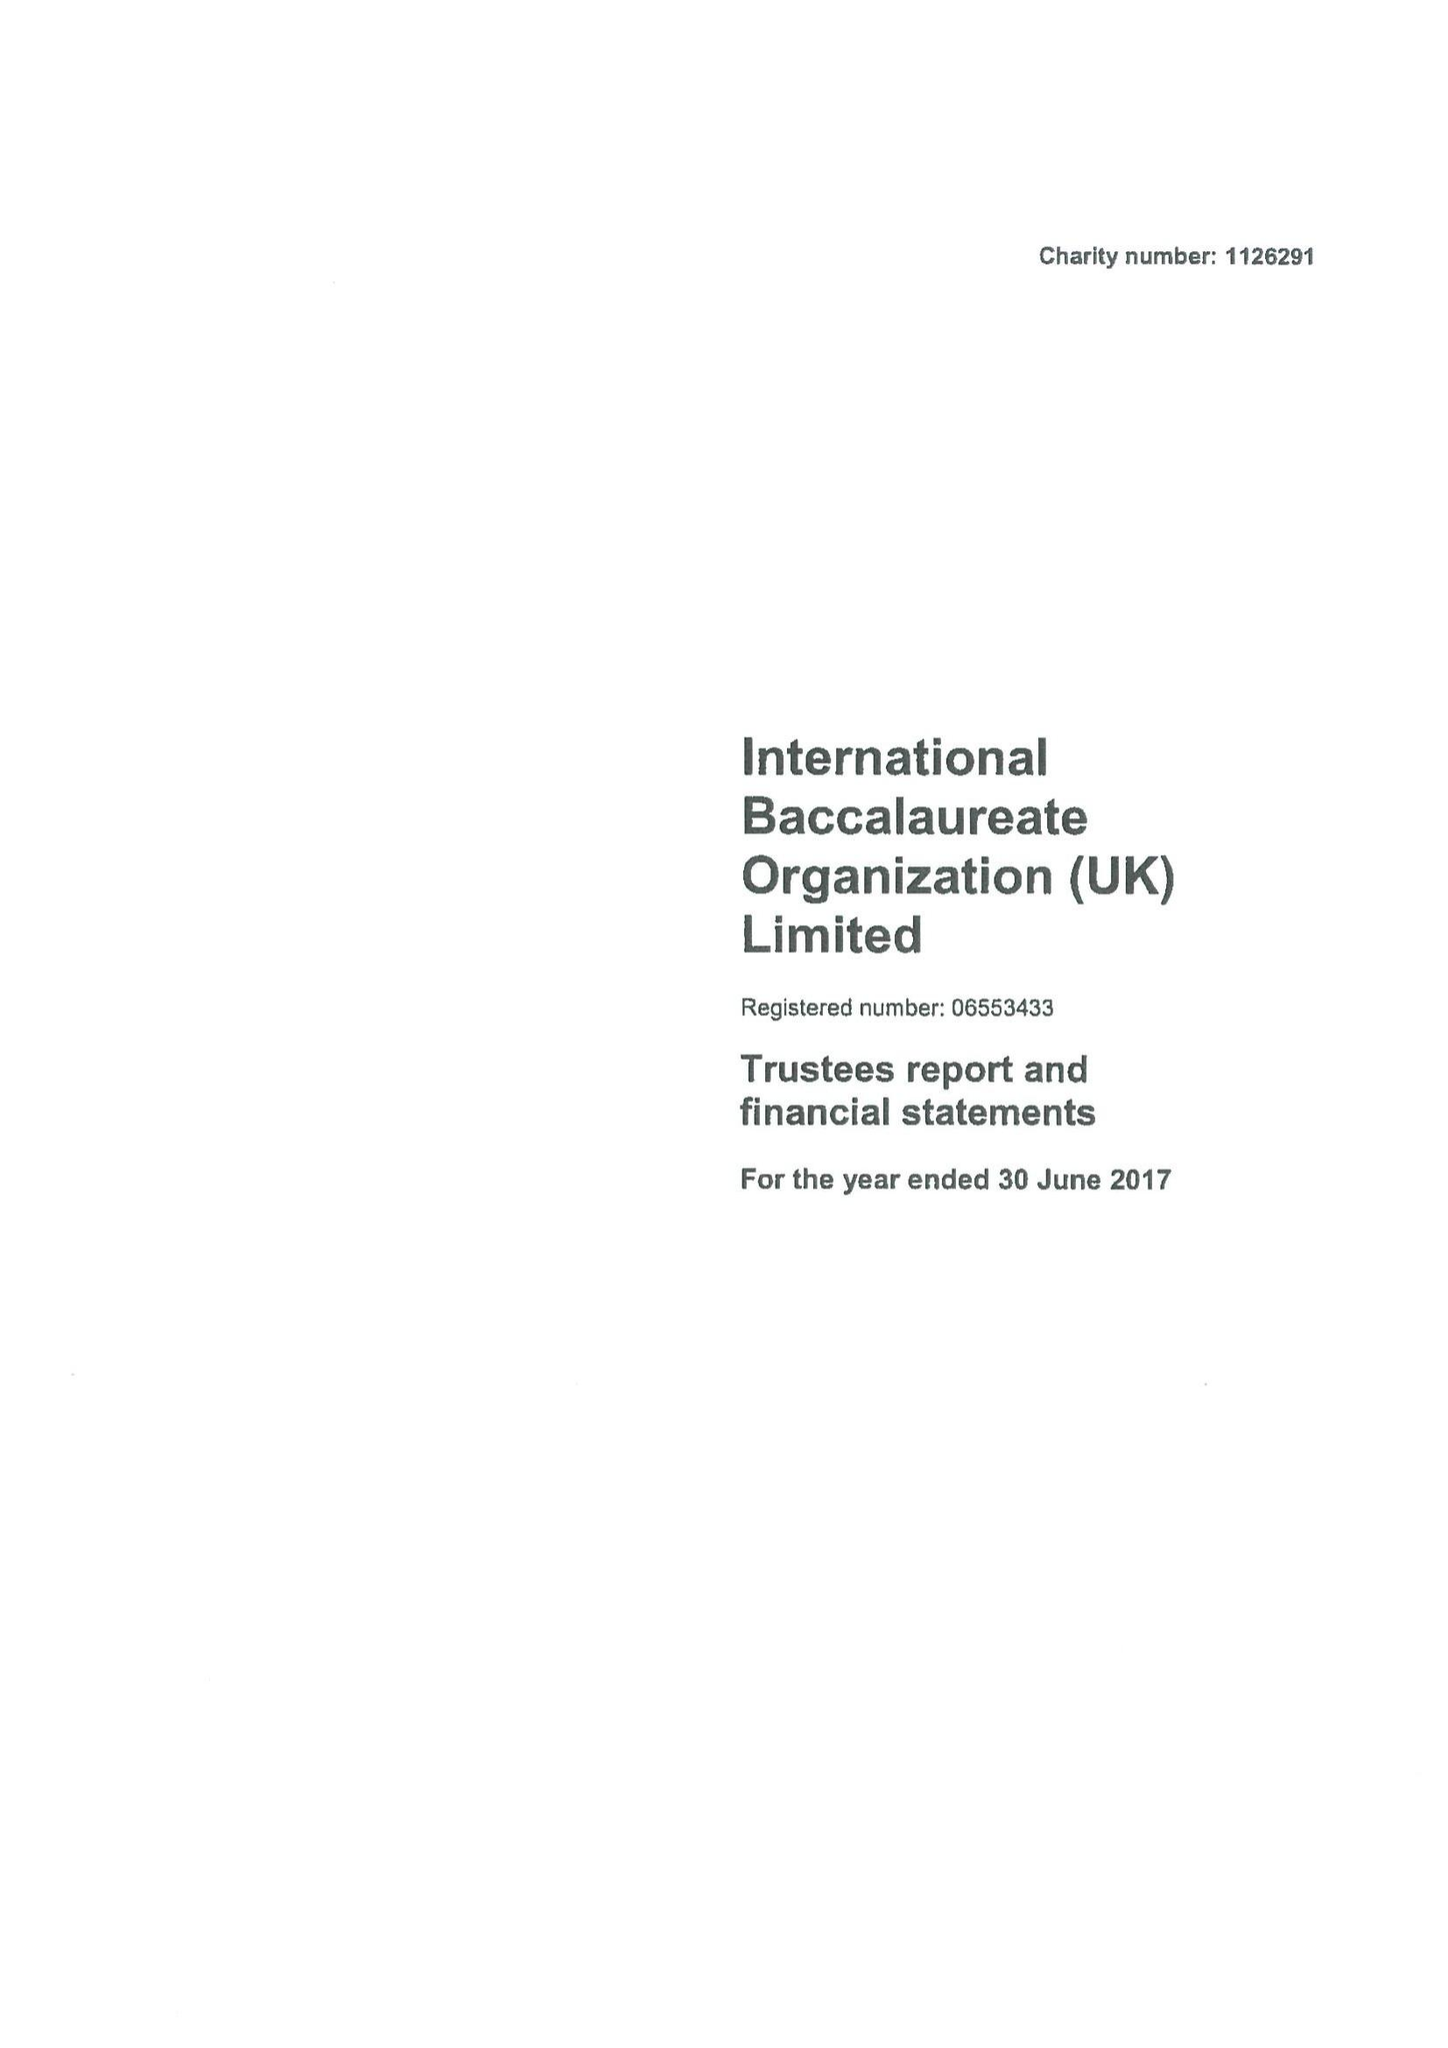What is the value for the report_date?
Answer the question using a single word or phrase. 2017-06-30 